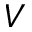Convert formula to latex. <formula><loc_0><loc_0><loc_500><loc_500>V</formula> 